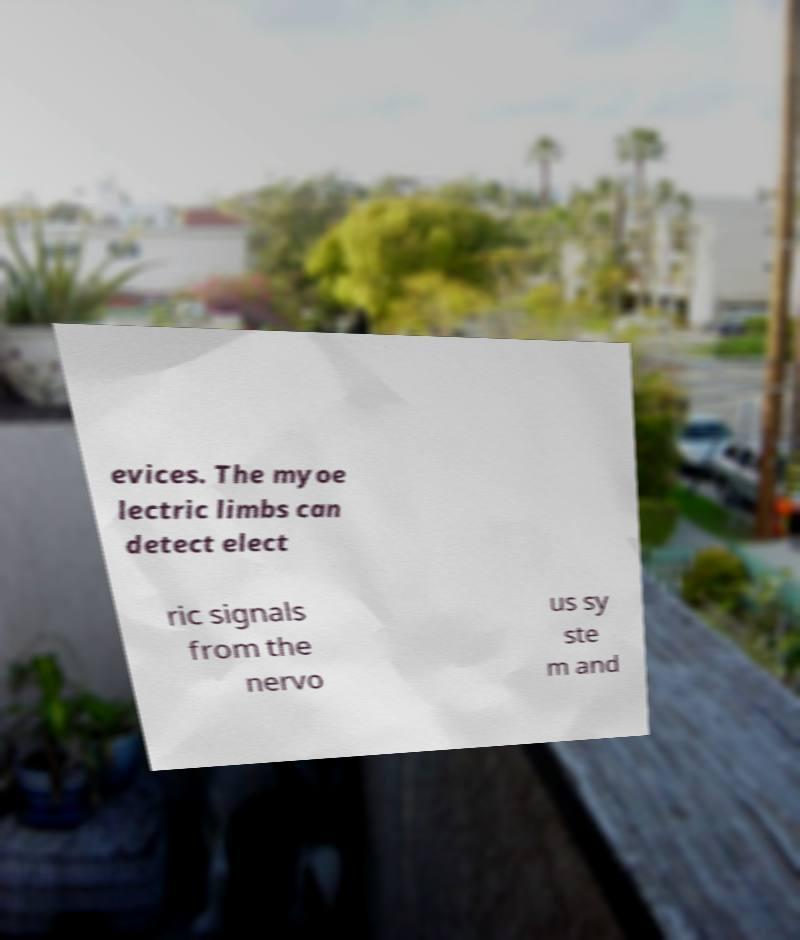Could you assist in decoding the text presented in this image and type it out clearly? evices. The myoe lectric limbs can detect elect ric signals from the nervo us sy ste m and 